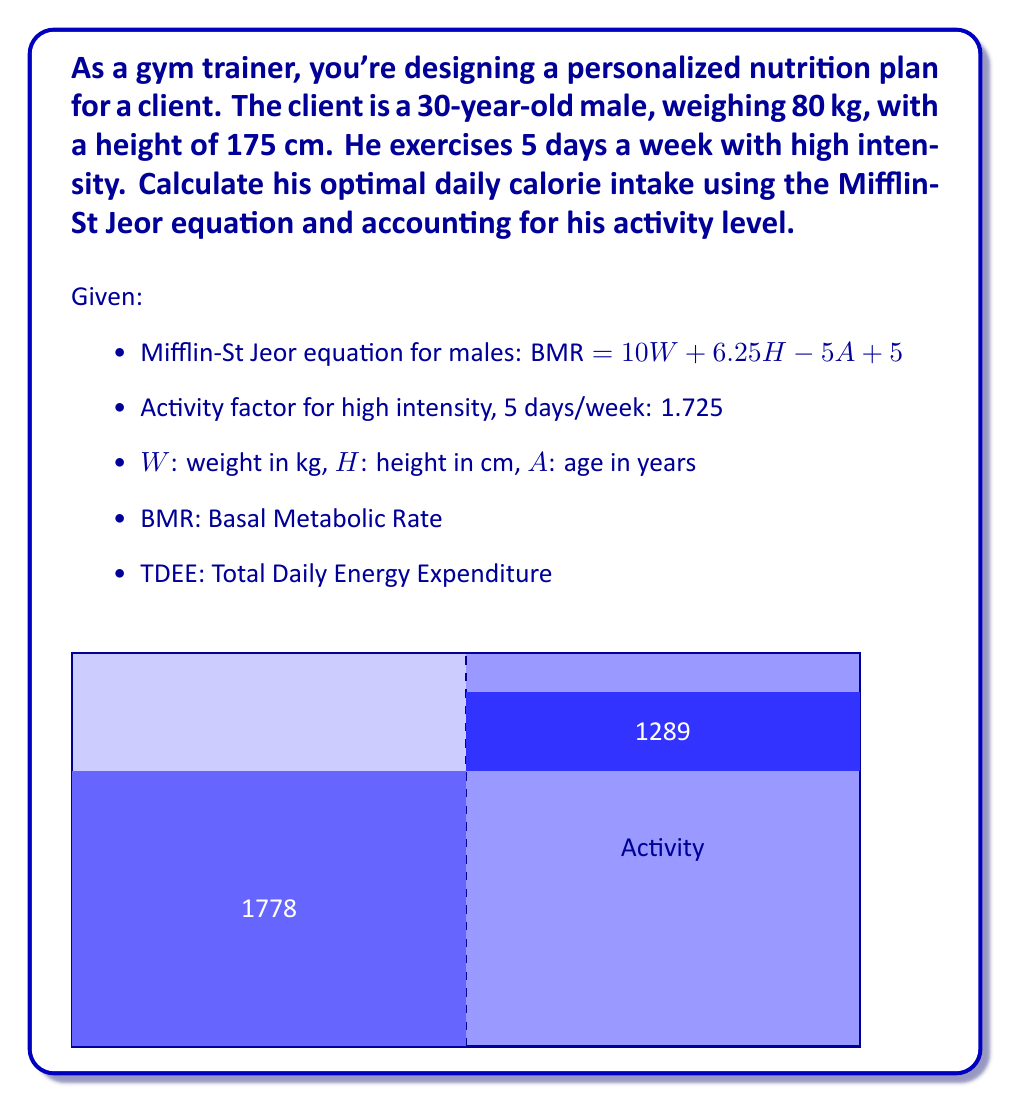What is the answer to this math problem? Let's solve this problem step by step:

1) First, calculate the Basal Metabolic Rate (BMR) using the Mifflin-St Jeor equation:

   BMR = 10W + 6.25H - 5A + 5
   
   Where:
   W = 80 kg
   H = 175 cm
   A = 30 years

   $$\begin{align}
   BMR &= 10(80) + 6.25(175) - 5(30) + 5 \\
   &= 800 + 1093.75 - 150 + 5 \\
   &= 1748.75 \text{ calories}
   \end{align}$$

2) Now, we need to account for the client's activity level. We use the activity factor of 1.725 for high intensity exercise 5 days a week. This gives us the Total Daily Energy Expenditure (TDEE):

   $$\begin{align}
   TDEE &= BMR \times \text{Activity Factor} \\
   &= 1748.75 \times 1.725 \\
   &= 3016.59375 \text{ calories}
   \end{align}$$

3) Round to the nearest whole number for practical use:

   Optimal daily calorie intake ≈ 3017 calories

This calculation provides the estimated number of calories the client needs to maintain their current weight while accounting for their high-intensity exercise routine. For weight loss or gain, this number would need to be adjusted accordingly.
Answer: 3017 calories 